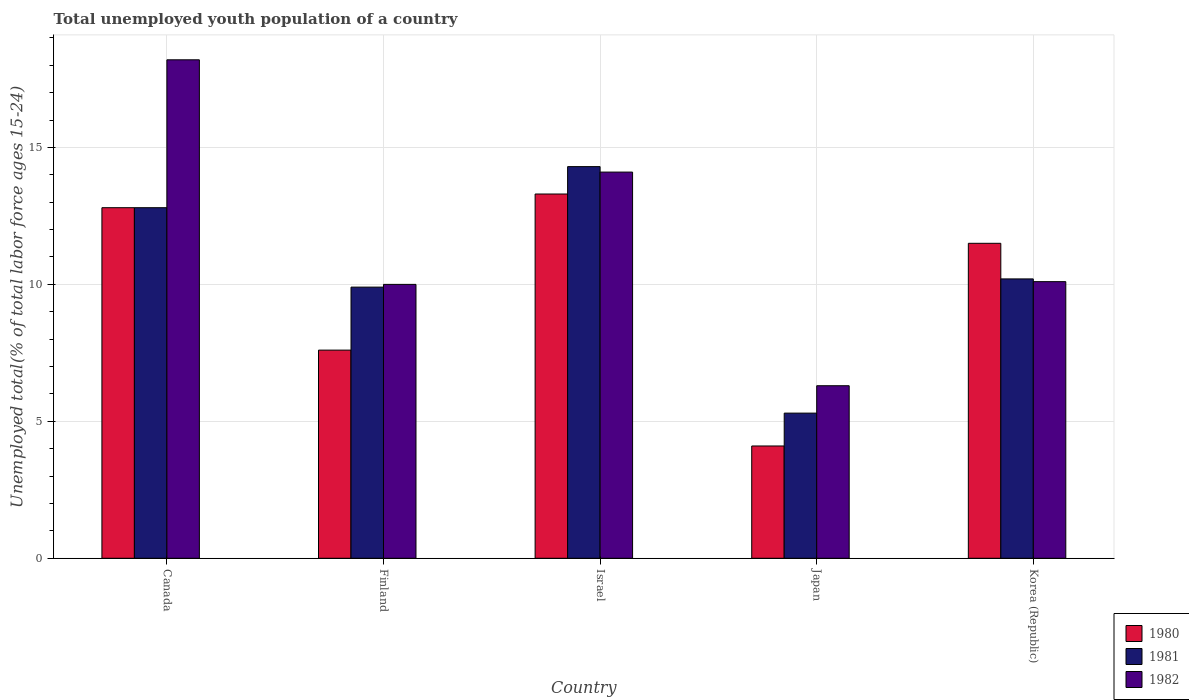How many different coloured bars are there?
Your answer should be compact. 3. Are the number of bars on each tick of the X-axis equal?
Offer a terse response. Yes. How many bars are there on the 3rd tick from the right?
Your answer should be very brief. 3. What is the percentage of total unemployed youth population of a country in 1982 in Korea (Republic)?
Make the answer very short. 10.1. Across all countries, what is the maximum percentage of total unemployed youth population of a country in 1982?
Provide a succinct answer. 18.2. Across all countries, what is the minimum percentage of total unemployed youth population of a country in 1982?
Keep it short and to the point. 6.3. What is the total percentage of total unemployed youth population of a country in 1980 in the graph?
Your response must be concise. 49.3. What is the difference between the percentage of total unemployed youth population of a country in 1981 in Canada and that in Finland?
Give a very brief answer. 2.9. What is the difference between the percentage of total unemployed youth population of a country in 1980 in Israel and the percentage of total unemployed youth population of a country in 1982 in Korea (Republic)?
Provide a short and direct response. 3.2. What is the average percentage of total unemployed youth population of a country in 1980 per country?
Provide a short and direct response. 9.86. What is the difference between the percentage of total unemployed youth population of a country of/in 1982 and percentage of total unemployed youth population of a country of/in 1980 in Finland?
Ensure brevity in your answer.  2.4. In how many countries, is the percentage of total unemployed youth population of a country in 1982 greater than 16 %?
Offer a very short reply. 1. What is the ratio of the percentage of total unemployed youth population of a country in 1982 in Canada to that in Finland?
Make the answer very short. 1.82. What is the difference between the highest and the second highest percentage of total unemployed youth population of a country in 1981?
Your answer should be compact. -2.6. What is the difference between the highest and the lowest percentage of total unemployed youth population of a country in 1982?
Ensure brevity in your answer.  11.9. In how many countries, is the percentage of total unemployed youth population of a country in 1981 greater than the average percentage of total unemployed youth population of a country in 1981 taken over all countries?
Offer a terse response. 2. Is the sum of the percentage of total unemployed youth population of a country in 1982 in Israel and Japan greater than the maximum percentage of total unemployed youth population of a country in 1980 across all countries?
Your answer should be compact. Yes. What does the 1st bar from the left in Israel represents?
Keep it short and to the point. 1980. What does the 2nd bar from the right in Korea (Republic) represents?
Ensure brevity in your answer.  1981. Is it the case that in every country, the sum of the percentage of total unemployed youth population of a country in 1980 and percentage of total unemployed youth population of a country in 1981 is greater than the percentage of total unemployed youth population of a country in 1982?
Offer a terse response. Yes. How many bars are there?
Give a very brief answer. 15. Are all the bars in the graph horizontal?
Your answer should be compact. No. How many countries are there in the graph?
Make the answer very short. 5. Are the values on the major ticks of Y-axis written in scientific E-notation?
Provide a short and direct response. No. Does the graph contain any zero values?
Ensure brevity in your answer.  No. Where does the legend appear in the graph?
Offer a terse response. Bottom right. How many legend labels are there?
Provide a succinct answer. 3. What is the title of the graph?
Provide a short and direct response. Total unemployed youth population of a country. What is the label or title of the Y-axis?
Offer a terse response. Unemployed total(% of total labor force ages 15-24). What is the Unemployed total(% of total labor force ages 15-24) in 1980 in Canada?
Ensure brevity in your answer.  12.8. What is the Unemployed total(% of total labor force ages 15-24) of 1981 in Canada?
Offer a very short reply. 12.8. What is the Unemployed total(% of total labor force ages 15-24) in 1982 in Canada?
Provide a succinct answer. 18.2. What is the Unemployed total(% of total labor force ages 15-24) of 1980 in Finland?
Your response must be concise. 7.6. What is the Unemployed total(% of total labor force ages 15-24) of 1981 in Finland?
Offer a terse response. 9.9. What is the Unemployed total(% of total labor force ages 15-24) of 1982 in Finland?
Your answer should be very brief. 10. What is the Unemployed total(% of total labor force ages 15-24) of 1980 in Israel?
Offer a terse response. 13.3. What is the Unemployed total(% of total labor force ages 15-24) in 1981 in Israel?
Your answer should be compact. 14.3. What is the Unemployed total(% of total labor force ages 15-24) of 1982 in Israel?
Offer a very short reply. 14.1. What is the Unemployed total(% of total labor force ages 15-24) in 1980 in Japan?
Your answer should be very brief. 4.1. What is the Unemployed total(% of total labor force ages 15-24) of 1981 in Japan?
Ensure brevity in your answer.  5.3. What is the Unemployed total(% of total labor force ages 15-24) in 1982 in Japan?
Your response must be concise. 6.3. What is the Unemployed total(% of total labor force ages 15-24) in 1980 in Korea (Republic)?
Provide a short and direct response. 11.5. What is the Unemployed total(% of total labor force ages 15-24) in 1981 in Korea (Republic)?
Your response must be concise. 10.2. What is the Unemployed total(% of total labor force ages 15-24) in 1982 in Korea (Republic)?
Give a very brief answer. 10.1. Across all countries, what is the maximum Unemployed total(% of total labor force ages 15-24) in 1980?
Your response must be concise. 13.3. Across all countries, what is the maximum Unemployed total(% of total labor force ages 15-24) in 1981?
Your answer should be very brief. 14.3. Across all countries, what is the maximum Unemployed total(% of total labor force ages 15-24) in 1982?
Your response must be concise. 18.2. Across all countries, what is the minimum Unemployed total(% of total labor force ages 15-24) of 1980?
Keep it short and to the point. 4.1. Across all countries, what is the minimum Unemployed total(% of total labor force ages 15-24) in 1981?
Your response must be concise. 5.3. Across all countries, what is the minimum Unemployed total(% of total labor force ages 15-24) in 1982?
Your answer should be compact. 6.3. What is the total Unemployed total(% of total labor force ages 15-24) of 1980 in the graph?
Offer a terse response. 49.3. What is the total Unemployed total(% of total labor force ages 15-24) of 1981 in the graph?
Provide a short and direct response. 52.5. What is the total Unemployed total(% of total labor force ages 15-24) in 1982 in the graph?
Your answer should be compact. 58.7. What is the difference between the Unemployed total(% of total labor force ages 15-24) of 1980 in Canada and that in Finland?
Give a very brief answer. 5.2. What is the difference between the Unemployed total(% of total labor force ages 15-24) of 1981 in Canada and that in Israel?
Offer a very short reply. -1.5. What is the difference between the Unemployed total(% of total labor force ages 15-24) of 1982 in Canada and that in Israel?
Your answer should be compact. 4.1. What is the difference between the Unemployed total(% of total labor force ages 15-24) in 1980 in Canada and that in Japan?
Give a very brief answer. 8.7. What is the difference between the Unemployed total(% of total labor force ages 15-24) of 1980 in Canada and that in Korea (Republic)?
Offer a very short reply. 1.3. What is the difference between the Unemployed total(% of total labor force ages 15-24) in 1981 in Canada and that in Korea (Republic)?
Offer a very short reply. 2.6. What is the difference between the Unemployed total(% of total labor force ages 15-24) of 1982 in Canada and that in Korea (Republic)?
Make the answer very short. 8.1. What is the difference between the Unemployed total(% of total labor force ages 15-24) of 1981 in Finland and that in Israel?
Make the answer very short. -4.4. What is the difference between the Unemployed total(% of total labor force ages 15-24) of 1981 in Finland and that in Korea (Republic)?
Your answer should be very brief. -0.3. What is the difference between the Unemployed total(% of total labor force ages 15-24) of 1981 in Israel and that in Japan?
Give a very brief answer. 9. What is the difference between the Unemployed total(% of total labor force ages 15-24) of 1980 in Israel and that in Korea (Republic)?
Make the answer very short. 1.8. What is the difference between the Unemployed total(% of total labor force ages 15-24) in 1980 in Japan and that in Korea (Republic)?
Make the answer very short. -7.4. What is the difference between the Unemployed total(% of total labor force ages 15-24) of 1981 in Japan and that in Korea (Republic)?
Your response must be concise. -4.9. What is the difference between the Unemployed total(% of total labor force ages 15-24) in 1980 in Canada and the Unemployed total(% of total labor force ages 15-24) in 1982 in Finland?
Offer a very short reply. 2.8. What is the difference between the Unemployed total(% of total labor force ages 15-24) of 1981 in Canada and the Unemployed total(% of total labor force ages 15-24) of 1982 in Finland?
Your answer should be very brief. 2.8. What is the difference between the Unemployed total(% of total labor force ages 15-24) of 1980 in Canada and the Unemployed total(% of total labor force ages 15-24) of 1981 in Israel?
Your answer should be compact. -1.5. What is the difference between the Unemployed total(% of total labor force ages 15-24) in 1980 in Canada and the Unemployed total(% of total labor force ages 15-24) in 1981 in Japan?
Give a very brief answer. 7.5. What is the difference between the Unemployed total(% of total labor force ages 15-24) of 1980 in Canada and the Unemployed total(% of total labor force ages 15-24) of 1982 in Japan?
Ensure brevity in your answer.  6.5. What is the difference between the Unemployed total(% of total labor force ages 15-24) in 1980 in Canada and the Unemployed total(% of total labor force ages 15-24) in 1981 in Korea (Republic)?
Offer a terse response. 2.6. What is the difference between the Unemployed total(% of total labor force ages 15-24) in 1980 in Canada and the Unemployed total(% of total labor force ages 15-24) in 1982 in Korea (Republic)?
Your answer should be compact. 2.7. What is the difference between the Unemployed total(% of total labor force ages 15-24) of 1980 in Finland and the Unemployed total(% of total labor force ages 15-24) of 1982 in Israel?
Provide a short and direct response. -6.5. What is the difference between the Unemployed total(% of total labor force ages 15-24) of 1981 in Finland and the Unemployed total(% of total labor force ages 15-24) of 1982 in Israel?
Your answer should be very brief. -4.2. What is the difference between the Unemployed total(% of total labor force ages 15-24) in 1980 in Finland and the Unemployed total(% of total labor force ages 15-24) in 1981 in Japan?
Your response must be concise. 2.3. What is the difference between the Unemployed total(% of total labor force ages 15-24) in 1980 in Finland and the Unemployed total(% of total labor force ages 15-24) in 1982 in Japan?
Your response must be concise. 1.3. What is the difference between the Unemployed total(% of total labor force ages 15-24) of 1980 in Finland and the Unemployed total(% of total labor force ages 15-24) of 1982 in Korea (Republic)?
Offer a terse response. -2.5. What is the difference between the Unemployed total(% of total labor force ages 15-24) in 1981 in Finland and the Unemployed total(% of total labor force ages 15-24) in 1982 in Korea (Republic)?
Offer a terse response. -0.2. What is the difference between the Unemployed total(% of total labor force ages 15-24) in 1981 in Israel and the Unemployed total(% of total labor force ages 15-24) in 1982 in Japan?
Ensure brevity in your answer.  8. What is the difference between the Unemployed total(% of total labor force ages 15-24) of 1980 in Japan and the Unemployed total(% of total labor force ages 15-24) of 1981 in Korea (Republic)?
Offer a terse response. -6.1. What is the difference between the Unemployed total(% of total labor force ages 15-24) of 1980 in Japan and the Unemployed total(% of total labor force ages 15-24) of 1982 in Korea (Republic)?
Your answer should be very brief. -6. What is the difference between the Unemployed total(% of total labor force ages 15-24) of 1981 in Japan and the Unemployed total(% of total labor force ages 15-24) of 1982 in Korea (Republic)?
Ensure brevity in your answer.  -4.8. What is the average Unemployed total(% of total labor force ages 15-24) of 1980 per country?
Provide a short and direct response. 9.86. What is the average Unemployed total(% of total labor force ages 15-24) of 1981 per country?
Make the answer very short. 10.5. What is the average Unemployed total(% of total labor force ages 15-24) in 1982 per country?
Provide a short and direct response. 11.74. What is the difference between the Unemployed total(% of total labor force ages 15-24) in 1981 and Unemployed total(% of total labor force ages 15-24) in 1982 in Canada?
Ensure brevity in your answer.  -5.4. What is the difference between the Unemployed total(% of total labor force ages 15-24) of 1980 and Unemployed total(% of total labor force ages 15-24) of 1982 in Finland?
Offer a terse response. -2.4. What is the difference between the Unemployed total(% of total labor force ages 15-24) in 1981 and Unemployed total(% of total labor force ages 15-24) in 1982 in Finland?
Your answer should be very brief. -0.1. What is the difference between the Unemployed total(% of total labor force ages 15-24) of 1980 and Unemployed total(% of total labor force ages 15-24) of 1981 in Israel?
Provide a succinct answer. -1. What is the difference between the Unemployed total(% of total labor force ages 15-24) in 1980 and Unemployed total(% of total labor force ages 15-24) in 1982 in Israel?
Provide a succinct answer. -0.8. What is the difference between the Unemployed total(% of total labor force ages 15-24) in 1980 and Unemployed total(% of total labor force ages 15-24) in 1982 in Japan?
Provide a succinct answer. -2.2. What is the difference between the Unemployed total(% of total labor force ages 15-24) in 1981 and Unemployed total(% of total labor force ages 15-24) in 1982 in Japan?
Your answer should be compact. -1. What is the difference between the Unemployed total(% of total labor force ages 15-24) of 1980 and Unemployed total(% of total labor force ages 15-24) of 1981 in Korea (Republic)?
Provide a succinct answer. 1.3. What is the difference between the Unemployed total(% of total labor force ages 15-24) in 1981 and Unemployed total(% of total labor force ages 15-24) in 1982 in Korea (Republic)?
Offer a terse response. 0.1. What is the ratio of the Unemployed total(% of total labor force ages 15-24) of 1980 in Canada to that in Finland?
Keep it short and to the point. 1.68. What is the ratio of the Unemployed total(% of total labor force ages 15-24) in 1981 in Canada to that in Finland?
Keep it short and to the point. 1.29. What is the ratio of the Unemployed total(% of total labor force ages 15-24) in 1982 in Canada to that in Finland?
Offer a terse response. 1.82. What is the ratio of the Unemployed total(% of total labor force ages 15-24) of 1980 in Canada to that in Israel?
Keep it short and to the point. 0.96. What is the ratio of the Unemployed total(% of total labor force ages 15-24) of 1981 in Canada to that in Israel?
Provide a short and direct response. 0.9. What is the ratio of the Unemployed total(% of total labor force ages 15-24) in 1982 in Canada to that in Israel?
Ensure brevity in your answer.  1.29. What is the ratio of the Unemployed total(% of total labor force ages 15-24) of 1980 in Canada to that in Japan?
Keep it short and to the point. 3.12. What is the ratio of the Unemployed total(% of total labor force ages 15-24) in 1981 in Canada to that in Japan?
Your answer should be compact. 2.42. What is the ratio of the Unemployed total(% of total labor force ages 15-24) in 1982 in Canada to that in Japan?
Give a very brief answer. 2.89. What is the ratio of the Unemployed total(% of total labor force ages 15-24) in 1980 in Canada to that in Korea (Republic)?
Ensure brevity in your answer.  1.11. What is the ratio of the Unemployed total(% of total labor force ages 15-24) in 1981 in Canada to that in Korea (Republic)?
Ensure brevity in your answer.  1.25. What is the ratio of the Unemployed total(% of total labor force ages 15-24) in 1982 in Canada to that in Korea (Republic)?
Keep it short and to the point. 1.8. What is the ratio of the Unemployed total(% of total labor force ages 15-24) in 1980 in Finland to that in Israel?
Keep it short and to the point. 0.57. What is the ratio of the Unemployed total(% of total labor force ages 15-24) in 1981 in Finland to that in Israel?
Keep it short and to the point. 0.69. What is the ratio of the Unemployed total(% of total labor force ages 15-24) of 1982 in Finland to that in Israel?
Your response must be concise. 0.71. What is the ratio of the Unemployed total(% of total labor force ages 15-24) of 1980 in Finland to that in Japan?
Your response must be concise. 1.85. What is the ratio of the Unemployed total(% of total labor force ages 15-24) in 1981 in Finland to that in Japan?
Provide a short and direct response. 1.87. What is the ratio of the Unemployed total(% of total labor force ages 15-24) of 1982 in Finland to that in Japan?
Provide a short and direct response. 1.59. What is the ratio of the Unemployed total(% of total labor force ages 15-24) of 1980 in Finland to that in Korea (Republic)?
Your response must be concise. 0.66. What is the ratio of the Unemployed total(% of total labor force ages 15-24) of 1981 in Finland to that in Korea (Republic)?
Provide a succinct answer. 0.97. What is the ratio of the Unemployed total(% of total labor force ages 15-24) in 1982 in Finland to that in Korea (Republic)?
Keep it short and to the point. 0.99. What is the ratio of the Unemployed total(% of total labor force ages 15-24) in 1980 in Israel to that in Japan?
Offer a terse response. 3.24. What is the ratio of the Unemployed total(% of total labor force ages 15-24) in 1981 in Israel to that in Japan?
Offer a terse response. 2.7. What is the ratio of the Unemployed total(% of total labor force ages 15-24) in 1982 in Israel to that in Japan?
Ensure brevity in your answer.  2.24. What is the ratio of the Unemployed total(% of total labor force ages 15-24) in 1980 in Israel to that in Korea (Republic)?
Your response must be concise. 1.16. What is the ratio of the Unemployed total(% of total labor force ages 15-24) of 1981 in Israel to that in Korea (Republic)?
Make the answer very short. 1.4. What is the ratio of the Unemployed total(% of total labor force ages 15-24) in 1982 in Israel to that in Korea (Republic)?
Your answer should be very brief. 1.4. What is the ratio of the Unemployed total(% of total labor force ages 15-24) in 1980 in Japan to that in Korea (Republic)?
Provide a succinct answer. 0.36. What is the ratio of the Unemployed total(% of total labor force ages 15-24) of 1981 in Japan to that in Korea (Republic)?
Ensure brevity in your answer.  0.52. What is the ratio of the Unemployed total(% of total labor force ages 15-24) in 1982 in Japan to that in Korea (Republic)?
Make the answer very short. 0.62. What is the difference between the highest and the second highest Unemployed total(% of total labor force ages 15-24) in 1980?
Your answer should be very brief. 0.5. What is the difference between the highest and the second highest Unemployed total(% of total labor force ages 15-24) of 1982?
Your answer should be very brief. 4.1. What is the difference between the highest and the lowest Unemployed total(% of total labor force ages 15-24) of 1980?
Ensure brevity in your answer.  9.2. What is the difference between the highest and the lowest Unemployed total(% of total labor force ages 15-24) in 1981?
Offer a very short reply. 9. What is the difference between the highest and the lowest Unemployed total(% of total labor force ages 15-24) of 1982?
Offer a terse response. 11.9. 